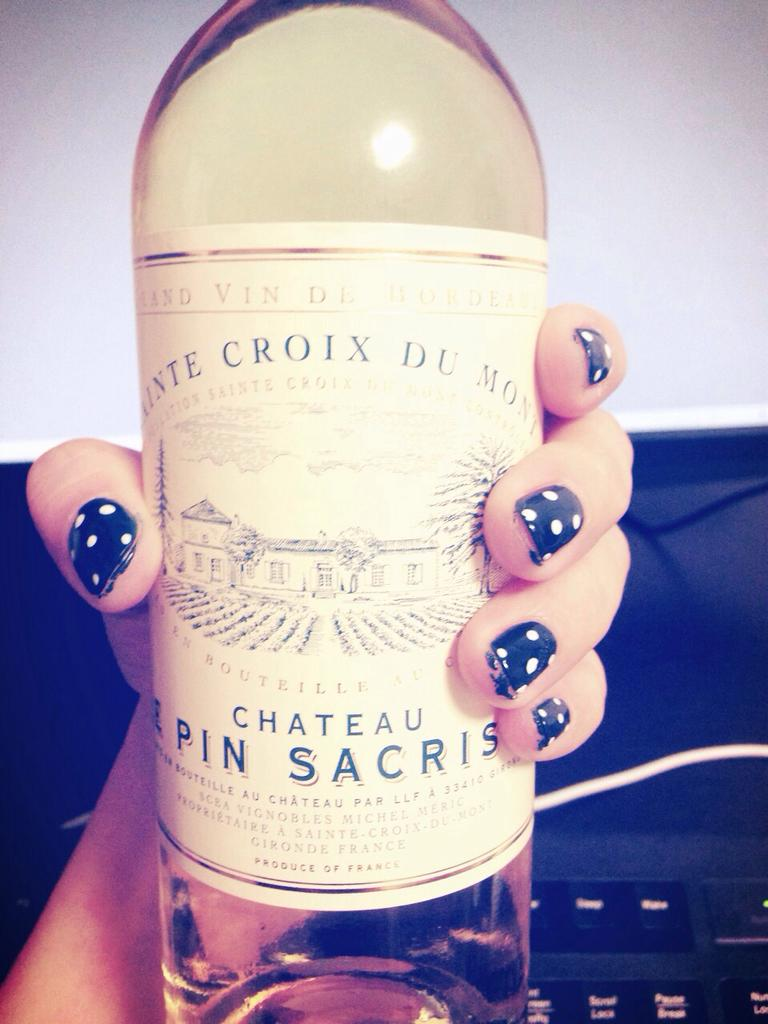What can be seen in the image? There is a hand of a person in the image. What is the hand holding? The hand is holding a bottle. How many sheep can be seen in the image? There are no sheep present in the image. What route is the person taking in the image? There is no route or indication of movement in the image, as it only shows a hand holding a bottle. 